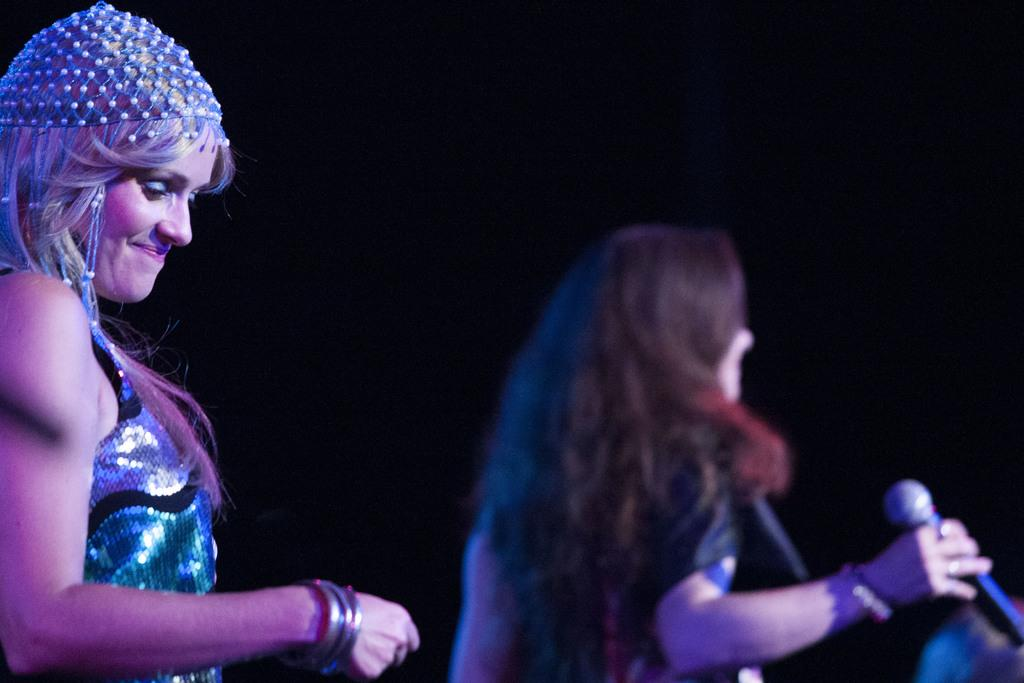How many women are present in the image? There are two women in the image. What is the facial expression of the first woman? The first woman has a smile on her face. What is the second woman holding in her hand? The second woman is holding a microphone in her hand. What type of bird can be seen flying in the background of the image? There are no birds visible in the image. Are there any tanks or spiders present in the image? No, there are no tanks or spiders present in the image. 